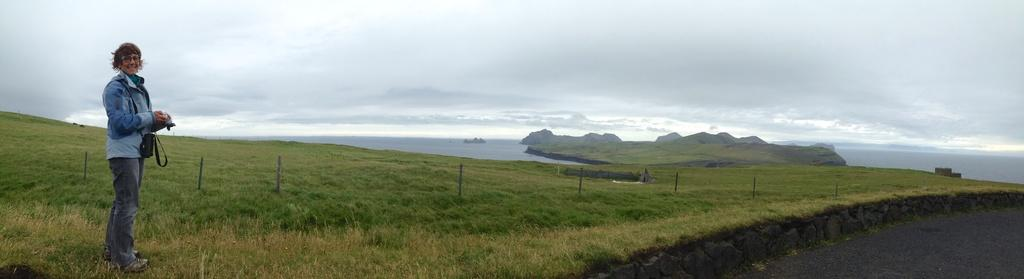What is the person on the left side of the image doing? The person is standing on the left side of the image and holding a camera. What can be seen on the right side of the side of the image? There is a road on the right side of the image. What is visible in the background of the image? In the background of the image, there is a fence, the sea, hills, and the sky. What type of coil is being used to create the art in the image? There is no coil or art present in the image; it features a person holding a camera and various background elements. 